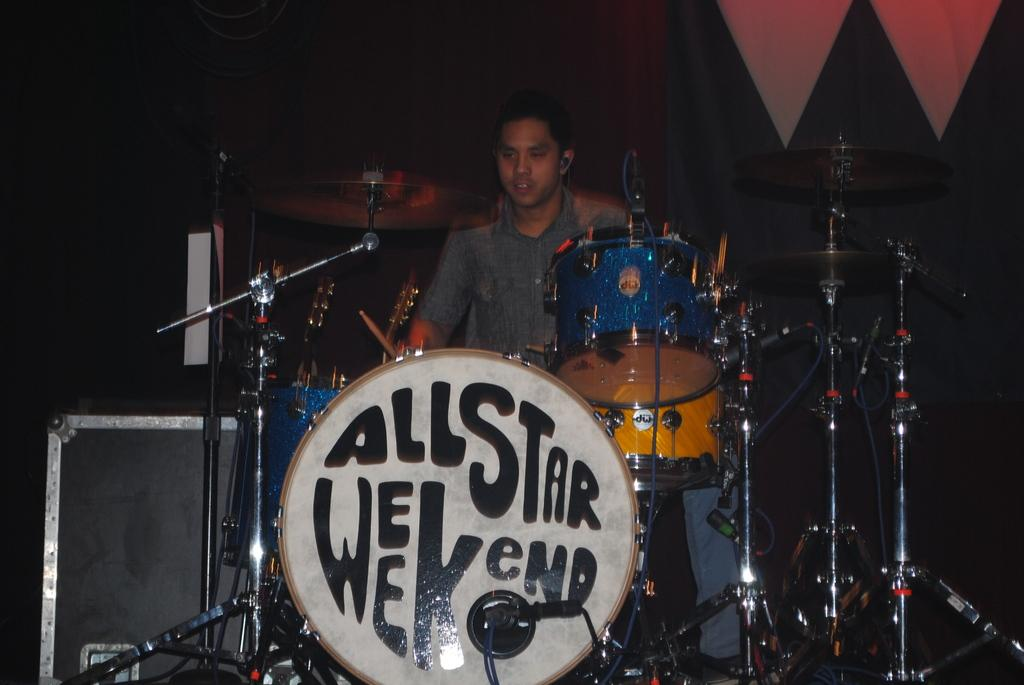What is the man in the image doing? The man is performing in the image. How is the man performing? The man is playing musical instruments. What is the purpose of the microphone on a stand in the image? The microphone on a stand is likely used for amplifying the man's voice while performing. Can you describe the background of the image? There is a box in the background of the image, as well as cloth on the right side and other objects visible. What type of tent can be seen in the image? There is no tent present in the image. How many knives are visible in the image? There are no knives visible in the image. 